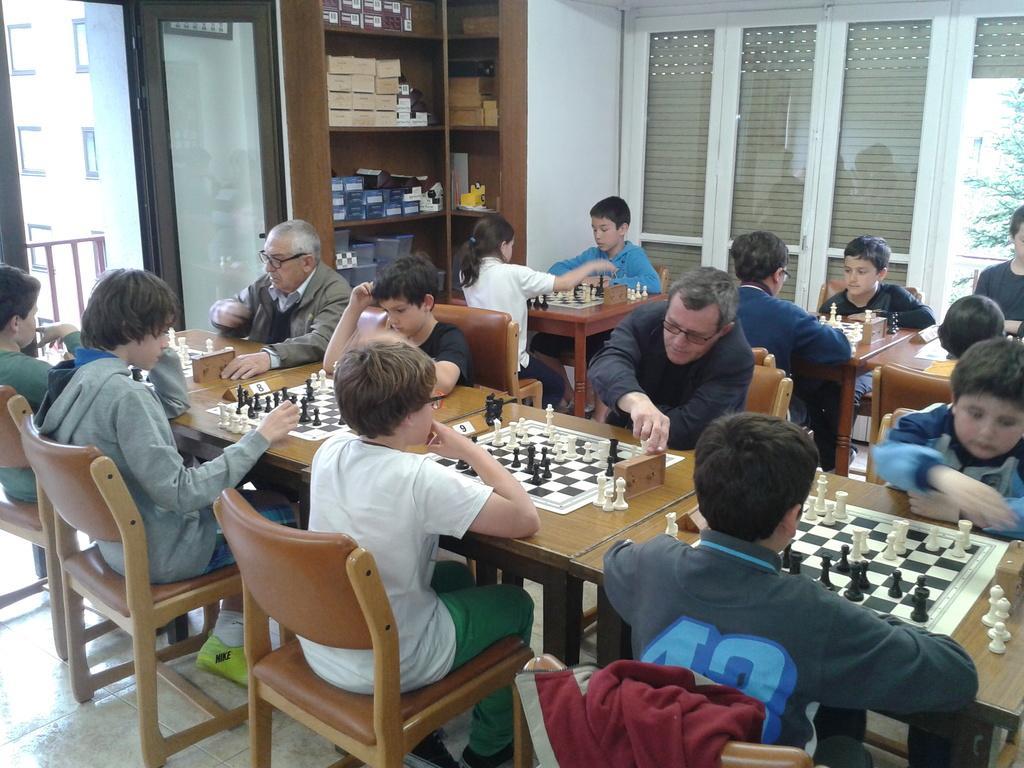In one or two sentences, can you explain what this image depicts? In this picture we can see some persons are sitting on the chairs. This is the table and these are the chess boards. And there is a wall, this is the rack. And this is the floor. 